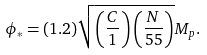Convert formula to latex. <formula><loc_0><loc_0><loc_500><loc_500>\phi _ { * } = ( 1 . 2 ) \sqrt { \left ( \frac { C } { 1 } \right ) \left ( \frac { N } { 5 5 } \right ) } M _ { p } .</formula> 